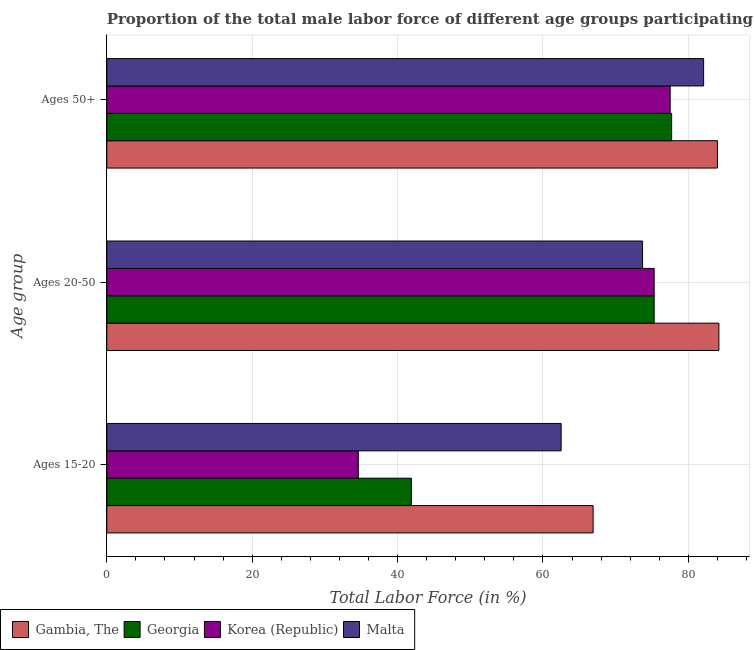How many different coloured bars are there?
Provide a succinct answer. 4. How many groups of bars are there?
Offer a very short reply. 3. Are the number of bars per tick equal to the number of legend labels?
Provide a succinct answer. Yes. How many bars are there on the 2nd tick from the top?
Your response must be concise. 4. What is the label of the 2nd group of bars from the top?
Keep it short and to the point. Ages 20-50. What is the percentage of male labor force within the age group 15-20 in Gambia, The?
Make the answer very short. 66.9. Across all countries, what is the maximum percentage of male labor force within the age group 20-50?
Give a very brief answer. 84.2. Across all countries, what is the minimum percentage of male labor force above age 50?
Make the answer very short. 77.5. In which country was the percentage of male labor force above age 50 maximum?
Provide a short and direct response. Gambia, The. In which country was the percentage of male labor force within the age group 20-50 minimum?
Provide a succinct answer. Malta. What is the total percentage of male labor force within the age group 20-50 in the graph?
Give a very brief answer. 308.5. What is the difference between the percentage of male labor force within the age group 20-50 in Georgia and that in Gambia, The?
Your answer should be very brief. -8.9. What is the difference between the percentage of male labor force within the age group 20-50 in Gambia, The and the percentage of male labor force above age 50 in Korea (Republic)?
Make the answer very short. 6.7. What is the average percentage of male labor force within the age group 20-50 per country?
Keep it short and to the point. 77.12. What is the difference between the percentage of male labor force within the age group 20-50 and percentage of male labor force above age 50 in Korea (Republic)?
Ensure brevity in your answer.  -2.2. What is the ratio of the percentage of male labor force within the age group 15-20 in Georgia to that in Korea (Republic)?
Give a very brief answer. 1.21. Is the difference between the percentage of male labor force above age 50 in Malta and Korea (Republic) greater than the difference between the percentage of male labor force within the age group 20-50 in Malta and Korea (Republic)?
Your answer should be compact. Yes. What is the difference between the highest and the second highest percentage of male labor force within the age group 15-20?
Provide a succinct answer. 4.4. What is the difference between the highest and the lowest percentage of male labor force within the age group 15-20?
Offer a very short reply. 32.3. In how many countries, is the percentage of male labor force within the age group 15-20 greater than the average percentage of male labor force within the age group 15-20 taken over all countries?
Make the answer very short. 2. What does the 3rd bar from the top in Ages 15-20 represents?
Offer a very short reply. Georgia. What does the 1st bar from the bottom in Ages 20-50 represents?
Your answer should be compact. Gambia, The. Are all the bars in the graph horizontal?
Provide a succinct answer. Yes. What is the difference between two consecutive major ticks on the X-axis?
Your answer should be very brief. 20. Are the values on the major ticks of X-axis written in scientific E-notation?
Your answer should be very brief. No. Does the graph contain any zero values?
Your response must be concise. No. Where does the legend appear in the graph?
Your answer should be compact. Bottom left. How many legend labels are there?
Your response must be concise. 4. What is the title of the graph?
Give a very brief answer. Proportion of the total male labor force of different age groups participating in production in 1997. Does "New Zealand" appear as one of the legend labels in the graph?
Your answer should be compact. No. What is the label or title of the X-axis?
Ensure brevity in your answer.  Total Labor Force (in %). What is the label or title of the Y-axis?
Offer a terse response. Age group. What is the Total Labor Force (in %) of Gambia, The in Ages 15-20?
Give a very brief answer. 66.9. What is the Total Labor Force (in %) in Georgia in Ages 15-20?
Provide a succinct answer. 41.9. What is the Total Labor Force (in %) in Korea (Republic) in Ages 15-20?
Offer a very short reply. 34.6. What is the Total Labor Force (in %) in Malta in Ages 15-20?
Offer a very short reply. 62.5. What is the Total Labor Force (in %) in Gambia, The in Ages 20-50?
Offer a terse response. 84.2. What is the Total Labor Force (in %) in Georgia in Ages 20-50?
Make the answer very short. 75.3. What is the Total Labor Force (in %) in Korea (Republic) in Ages 20-50?
Give a very brief answer. 75.3. What is the Total Labor Force (in %) of Malta in Ages 20-50?
Your answer should be compact. 73.7. What is the Total Labor Force (in %) in Gambia, The in Ages 50+?
Provide a succinct answer. 84. What is the Total Labor Force (in %) in Georgia in Ages 50+?
Provide a short and direct response. 77.7. What is the Total Labor Force (in %) of Korea (Republic) in Ages 50+?
Your response must be concise. 77.5. What is the Total Labor Force (in %) in Malta in Ages 50+?
Make the answer very short. 82.1. Across all Age group, what is the maximum Total Labor Force (in %) of Gambia, The?
Give a very brief answer. 84.2. Across all Age group, what is the maximum Total Labor Force (in %) of Georgia?
Provide a succinct answer. 77.7. Across all Age group, what is the maximum Total Labor Force (in %) of Korea (Republic)?
Ensure brevity in your answer.  77.5. Across all Age group, what is the maximum Total Labor Force (in %) in Malta?
Your answer should be very brief. 82.1. Across all Age group, what is the minimum Total Labor Force (in %) in Gambia, The?
Your answer should be compact. 66.9. Across all Age group, what is the minimum Total Labor Force (in %) of Georgia?
Your answer should be very brief. 41.9. Across all Age group, what is the minimum Total Labor Force (in %) in Korea (Republic)?
Provide a short and direct response. 34.6. Across all Age group, what is the minimum Total Labor Force (in %) of Malta?
Offer a very short reply. 62.5. What is the total Total Labor Force (in %) of Gambia, The in the graph?
Offer a terse response. 235.1. What is the total Total Labor Force (in %) of Georgia in the graph?
Provide a short and direct response. 194.9. What is the total Total Labor Force (in %) in Korea (Republic) in the graph?
Keep it short and to the point. 187.4. What is the total Total Labor Force (in %) of Malta in the graph?
Ensure brevity in your answer.  218.3. What is the difference between the Total Labor Force (in %) in Gambia, The in Ages 15-20 and that in Ages 20-50?
Your answer should be compact. -17.3. What is the difference between the Total Labor Force (in %) of Georgia in Ages 15-20 and that in Ages 20-50?
Offer a terse response. -33.4. What is the difference between the Total Labor Force (in %) of Korea (Republic) in Ages 15-20 and that in Ages 20-50?
Your answer should be very brief. -40.7. What is the difference between the Total Labor Force (in %) in Malta in Ages 15-20 and that in Ages 20-50?
Your response must be concise. -11.2. What is the difference between the Total Labor Force (in %) of Gambia, The in Ages 15-20 and that in Ages 50+?
Keep it short and to the point. -17.1. What is the difference between the Total Labor Force (in %) in Georgia in Ages 15-20 and that in Ages 50+?
Your answer should be very brief. -35.8. What is the difference between the Total Labor Force (in %) of Korea (Republic) in Ages 15-20 and that in Ages 50+?
Your response must be concise. -42.9. What is the difference between the Total Labor Force (in %) in Malta in Ages 15-20 and that in Ages 50+?
Ensure brevity in your answer.  -19.6. What is the difference between the Total Labor Force (in %) of Malta in Ages 20-50 and that in Ages 50+?
Ensure brevity in your answer.  -8.4. What is the difference between the Total Labor Force (in %) of Gambia, The in Ages 15-20 and the Total Labor Force (in %) of Georgia in Ages 20-50?
Offer a very short reply. -8.4. What is the difference between the Total Labor Force (in %) in Gambia, The in Ages 15-20 and the Total Labor Force (in %) in Malta in Ages 20-50?
Ensure brevity in your answer.  -6.8. What is the difference between the Total Labor Force (in %) of Georgia in Ages 15-20 and the Total Labor Force (in %) of Korea (Republic) in Ages 20-50?
Offer a terse response. -33.4. What is the difference between the Total Labor Force (in %) in Georgia in Ages 15-20 and the Total Labor Force (in %) in Malta in Ages 20-50?
Provide a short and direct response. -31.8. What is the difference between the Total Labor Force (in %) of Korea (Republic) in Ages 15-20 and the Total Labor Force (in %) of Malta in Ages 20-50?
Provide a short and direct response. -39.1. What is the difference between the Total Labor Force (in %) of Gambia, The in Ages 15-20 and the Total Labor Force (in %) of Georgia in Ages 50+?
Your response must be concise. -10.8. What is the difference between the Total Labor Force (in %) of Gambia, The in Ages 15-20 and the Total Labor Force (in %) of Malta in Ages 50+?
Offer a very short reply. -15.2. What is the difference between the Total Labor Force (in %) in Georgia in Ages 15-20 and the Total Labor Force (in %) in Korea (Republic) in Ages 50+?
Ensure brevity in your answer.  -35.6. What is the difference between the Total Labor Force (in %) in Georgia in Ages 15-20 and the Total Labor Force (in %) in Malta in Ages 50+?
Offer a terse response. -40.2. What is the difference between the Total Labor Force (in %) of Korea (Republic) in Ages 15-20 and the Total Labor Force (in %) of Malta in Ages 50+?
Keep it short and to the point. -47.5. What is the difference between the Total Labor Force (in %) of Gambia, The in Ages 20-50 and the Total Labor Force (in %) of Georgia in Ages 50+?
Make the answer very short. 6.5. What is the difference between the Total Labor Force (in %) of Gambia, The in Ages 20-50 and the Total Labor Force (in %) of Malta in Ages 50+?
Offer a very short reply. 2.1. What is the difference between the Total Labor Force (in %) in Korea (Republic) in Ages 20-50 and the Total Labor Force (in %) in Malta in Ages 50+?
Provide a succinct answer. -6.8. What is the average Total Labor Force (in %) of Gambia, The per Age group?
Keep it short and to the point. 78.37. What is the average Total Labor Force (in %) of Georgia per Age group?
Your response must be concise. 64.97. What is the average Total Labor Force (in %) in Korea (Republic) per Age group?
Offer a very short reply. 62.47. What is the average Total Labor Force (in %) in Malta per Age group?
Make the answer very short. 72.77. What is the difference between the Total Labor Force (in %) of Gambia, The and Total Labor Force (in %) of Korea (Republic) in Ages 15-20?
Ensure brevity in your answer.  32.3. What is the difference between the Total Labor Force (in %) of Gambia, The and Total Labor Force (in %) of Malta in Ages 15-20?
Your answer should be very brief. 4.4. What is the difference between the Total Labor Force (in %) in Georgia and Total Labor Force (in %) in Korea (Republic) in Ages 15-20?
Ensure brevity in your answer.  7.3. What is the difference between the Total Labor Force (in %) in Georgia and Total Labor Force (in %) in Malta in Ages 15-20?
Provide a succinct answer. -20.6. What is the difference between the Total Labor Force (in %) in Korea (Republic) and Total Labor Force (in %) in Malta in Ages 15-20?
Your answer should be very brief. -27.9. What is the difference between the Total Labor Force (in %) of Gambia, The and Total Labor Force (in %) of Georgia in Ages 20-50?
Give a very brief answer. 8.9. What is the difference between the Total Labor Force (in %) in Gambia, The and Total Labor Force (in %) in Malta in Ages 20-50?
Provide a short and direct response. 10.5. What is the difference between the Total Labor Force (in %) in Georgia and Total Labor Force (in %) in Korea (Republic) in Ages 20-50?
Offer a terse response. 0. What is the difference between the Total Labor Force (in %) in Korea (Republic) and Total Labor Force (in %) in Malta in Ages 20-50?
Your answer should be compact. 1.6. What is the difference between the Total Labor Force (in %) of Gambia, The and Total Labor Force (in %) of Georgia in Ages 50+?
Offer a terse response. 6.3. What is the difference between the Total Labor Force (in %) of Gambia, The and Total Labor Force (in %) of Korea (Republic) in Ages 50+?
Offer a terse response. 6.5. What is the difference between the Total Labor Force (in %) in Gambia, The and Total Labor Force (in %) in Malta in Ages 50+?
Your answer should be very brief. 1.9. What is the difference between the Total Labor Force (in %) in Georgia and Total Labor Force (in %) in Korea (Republic) in Ages 50+?
Ensure brevity in your answer.  0.2. What is the difference between the Total Labor Force (in %) in Georgia and Total Labor Force (in %) in Malta in Ages 50+?
Provide a short and direct response. -4.4. What is the difference between the Total Labor Force (in %) of Korea (Republic) and Total Labor Force (in %) of Malta in Ages 50+?
Offer a terse response. -4.6. What is the ratio of the Total Labor Force (in %) of Gambia, The in Ages 15-20 to that in Ages 20-50?
Ensure brevity in your answer.  0.79. What is the ratio of the Total Labor Force (in %) in Georgia in Ages 15-20 to that in Ages 20-50?
Keep it short and to the point. 0.56. What is the ratio of the Total Labor Force (in %) in Korea (Republic) in Ages 15-20 to that in Ages 20-50?
Provide a short and direct response. 0.46. What is the ratio of the Total Labor Force (in %) in Malta in Ages 15-20 to that in Ages 20-50?
Make the answer very short. 0.85. What is the ratio of the Total Labor Force (in %) of Gambia, The in Ages 15-20 to that in Ages 50+?
Your answer should be very brief. 0.8. What is the ratio of the Total Labor Force (in %) of Georgia in Ages 15-20 to that in Ages 50+?
Offer a terse response. 0.54. What is the ratio of the Total Labor Force (in %) in Korea (Republic) in Ages 15-20 to that in Ages 50+?
Offer a terse response. 0.45. What is the ratio of the Total Labor Force (in %) in Malta in Ages 15-20 to that in Ages 50+?
Provide a short and direct response. 0.76. What is the ratio of the Total Labor Force (in %) of Gambia, The in Ages 20-50 to that in Ages 50+?
Keep it short and to the point. 1. What is the ratio of the Total Labor Force (in %) in Georgia in Ages 20-50 to that in Ages 50+?
Offer a terse response. 0.97. What is the ratio of the Total Labor Force (in %) in Korea (Republic) in Ages 20-50 to that in Ages 50+?
Your answer should be very brief. 0.97. What is the ratio of the Total Labor Force (in %) of Malta in Ages 20-50 to that in Ages 50+?
Provide a short and direct response. 0.9. What is the difference between the highest and the second highest Total Labor Force (in %) of Gambia, The?
Keep it short and to the point. 0.2. What is the difference between the highest and the second highest Total Labor Force (in %) of Korea (Republic)?
Provide a short and direct response. 2.2. What is the difference between the highest and the lowest Total Labor Force (in %) in Gambia, The?
Give a very brief answer. 17.3. What is the difference between the highest and the lowest Total Labor Force (in %) in Georgia?
Ensure brevity in your answer.  35.8. What is the difference between the highest and the lowest Total Labor Force (in %) of Korea (Republic)?
Your answer should be very brief. 42.9. What is the difference between the highest and the lowest Total Labor Force (in %) in Malta?
Give a very brief answer. 19.6. 